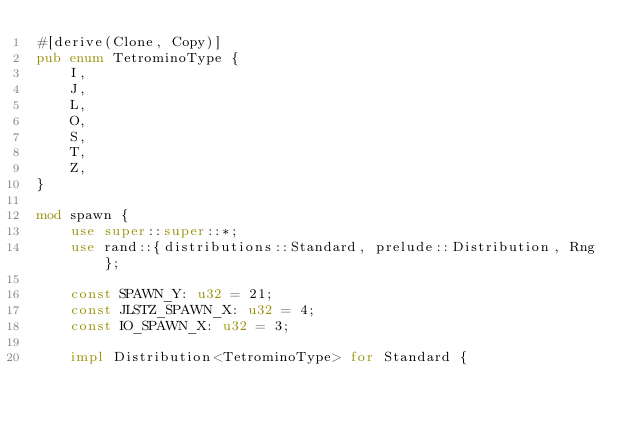<code> <loc_0><loc_0><loc_500><loc_500><_Rust_>#[derive(Clone, Copy)]
pub enum TetrominoType {
    I,
    J,
    L,
    O,
    S,
    T,
    Z,
}

mod spawn {
    use super::super::*;
    use rand::{distributions::Standard, prelude::Distribution, Rng};

    const SPAWN_Y: u32 = 21;
    const JLSTZ_SPAWN_X: u32 = 4;
    const IO_SPAWN_X: u32 = 3;

    impl Distribution<TetrominoType> for Standard {</code> 